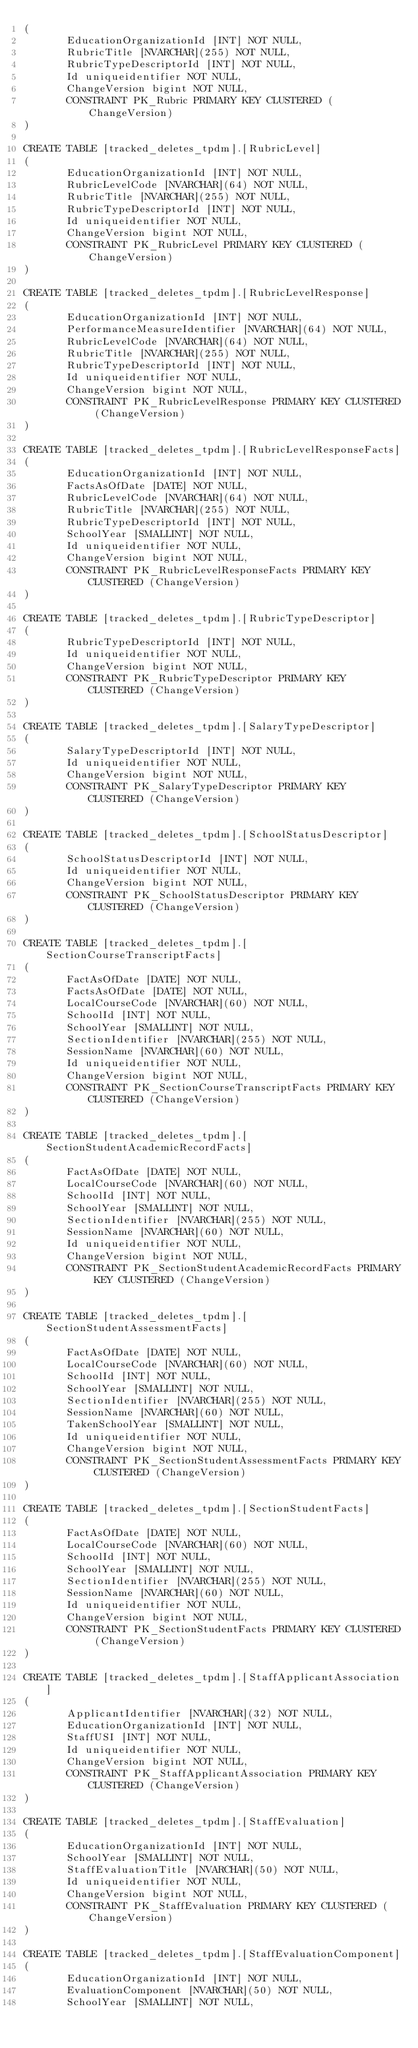<code> <loc_0><loc_0><loc_500><loc_500><_SQL_>(
       EducationOrganizationId [INT] NOT NULL,
       RubricTitle [NVARCHAR](255) NOT NULL,
       RubricTypeDescriptorId [INT] NOT NULL,
       Id uniqueidentifier NOT NULL,
       ChangeVersion bigint NOT NULL,
       CONSTRAINT PK_Rubric PRIMARY KEY CLUSTERED (ChangeVersion)
)

CREATE TABLE [tracked_deletes_tpdm].[RubricLevel]
(
       EducationOrganizationId [INT] NOT NULL,
       RubricLevelCode [NVARCHAR](64) NOT NULL,
       RubricTitle [NVARCHAR](255) NOT NULL,
       RubricTypeDescriptorId [INT] NOT NULL,
       Id uniqueidentifier NOT NULL,
       ChangeVersion bigint NOT NULL,
       CONSTRAINT PK_RubricLevel PRIMARY KEY CLUSTERED (ChangeVersion)
)

CREATE TABLE [tracked_deletes_tpdm].[RubricLevelResponse]
(
       EducationOrganizationId [INT] NOT NULL,
       PerformanceMeasureIdentifier [NVARCHAR](64) NOT NULL,
       RubricLevelCode [NVARCHAR](64) NOT NULL,
       RubricTitle [NVARCHAR](255) NOT NULL,
       RubricTypeDescriptorId [INT] NOT NULL,
       Id uniqueidentifier NOT NULL,
       ChangeVersion bigint NOT NULL,
       CONSTRAINT PK_RubricLevelResponse PRIMARY KEY CLUSTERED (ChangeVersion)
)

CREATE TABLE [tracked_deletes_tpdm].[RubricLevelResponseFacts]
(
       EducationOrganizationId [INT] NOT NULL,
       FactsAsOfDate [DATE] NOT NULL,
       RubricLevelCode [NVARCHAR](64) NOT NULL,
       RubricTitle [NVARCHAR](255) NOT NULL,
       RubricTypeDescriptorId [INT] NOT NULL,
       SchoolYear [SMALLINT] NOT NULL,
       Id uniqueidentifier NOT NULL,
       ChangeVersion bigint NOT NULL,
       CONSTRAINT PK_RubricLevelResponseFacts PRIMARY KEY CLUSTERED (ChangeVersion)
)

CREATE TABLE [tracked_deletes_tpdm].[RubricTypeDescriptor]
(
       RubricTypeDescriptorId [INT] NOT NULL,
       Id uniqueidentifier NOT NULL,
       ChangeVersion bigint NOT NULL,
       CONSTRAINT PK_RubricTypeDescriptor PRIMARY KEY CLUSTERED (ChangeVersion)
)

CREATE TABLE [tracked_deletes_tpdm].[SalaryTypeDescriptor]
(
       SalaryTypeDescriptorId [INT] NOT NULL,
       Id uniqueidentifier NOT NULL,
       ChangeVersion bigint NOT NULL,
       CONSTRAINT PK_SalaryTypeDescriptor PRIMARY KEY CLUSTERED (ChangeVersion)
)

CREATE TABLE [tracked_deletes_tpdm].[SchoolStatusDescriptor]
(
       SchoolStatusDescriptorId [INT] NOT NULL,
       Id uniqueidentifier NOT NULL,
       ChangeVersion bigint NOT NULL,
       CONSTRAINT PK_SchoolStatusDescriptor PRIMARY KEY CLUSTERED (ChangeVersion)
)

CREATE TABLE [tracked_deletes_tpdm].[SectionCourseTranscriptFacts]
(
       FactAsOfDate [DATE] NOT NULL,
       FactsAsOfDate [DATE] NOT NULL,
       LocalCourseCode [NVARCHAR](60) NOT NULL,
       SchoolId [INT] NOT NULL,
       SchoolYear [SMALLINT] NOT NULL,
       SectionIdentifier [NVARCHAR](255) NOT NULL,
       SessionName [NVARCHAR](60) NOT NULL,
       Id uniqueidentifier NOT NULL,
       ChangeVersion bigint NOT NULL,
       CONSTRAINT PK_SectionCourseTranscriptFacts PRIMARY KEY CLUSTERED (ChangeVersion)
)

CREATE TABLE [tracked_deletes_tpdm].[SectionStudentAcademicRecordFacts]
(
       FactAsOfDate [DATE] NOT NULL,
       LocalCourseCode [NVARCHAR](60) NOT NULL,
       SchoolId [INT] NOT NULL,
       SchoolYear [SMALLINT] NOT NULL,
       SectionIdentifier [NVARCHAR](255) NOT NULL,
       SessionName [NVARCHAR](60) NOT NULL,
       Id uniqueidentifier NOT NULL,
       ChangeVersion bigint NOT NULL,
       CONSTRAINT PK_SectionStudentAcademicRecordFacts PRIMARY KEY CLUSTERED (ChangeVersion)
)

CREATE TABLE [tracked_deletes_tpdm].[SectionStudentAssessmentFacts]
(
       FactAsOfDate [DATE] NOT NULL,
       LocalCourseCode [NVARCHAR](60) NOT NULL,
       SchoolId [INT] NOT NULL,
       SchoolYear [SMALLINT] NOT NULL,
       SectionIdentifier [NVARCHAR](255) NOT NULL,
       SessionName [NVARCHAR](60) NOT NULL,
       TakenSchoolYear [SMALLINT] NOT NULL,
       Id uniqueidentifier NOT NULL,
       ChangeVersion bigint NOT NULL,
       CONSTRAINT PK_SectionStudentAssessmentFacts PRIMARY KEY CLUSTERED (ChangeVersion)
)

CREATE TABLE [tracked_deletes_tpdm].[SectionStudentFacts]
(
       FactAsOfDate [DATE] NOT NULL,
       LocalCourseCode [NVARCHAR](60) NOT NULL,
       SchoolId [INT] NOT NULL,
       SchoolYear [SMALLINT] NOT NULL,
       SectionIdentifier [NVARCHAR](255) NOT NULL,
       SessionName [NVARCHAR](60) NOT NULL,
       Id uniqueidentifier NOT NULL,
       ChangeVersion bigint NOT NULL,
       CONSTRAINT PK_SectionStudentFacts PRIMARY KEY CLUSTERED (ChangeVersion)
)

CREATE TABLE [tracked_deletes_tpdm].[StaffApplicantAssociation]
(
       ApplicantIdentifier [NVARCHAR](32) NOT NULL,
       EducationOrganizationId [INT] NOT NULL,
       StaffUSI [INT] NOT NULL,
       Id uniqueidentifier NOT NULL,
       ChangeVersion bigint NOT NULL,
       CONSTRAINT PK_StaffApplicantAssociation PRIMARY KEY CLUSTERED (ChangeVersion)
)

CREATE TABLE [tracked_deletes_tpdm].[StaffEvaluation]
(
       EducationOrganizationId [INT] NOT NULL,
       SchoolYear [SMALLINT] NOT NULL,
       StaffEvaluationTitle [NVARCHAR](50) NOT NULL,
       Id uniqueidentifier NOT NULL,
       ChangeVersion bigint NOT NULL,
       CONSTRAINT PK_StaffEvaluation PRIMARY KEY CLUSTERED (ChangeVersion)
)

CREATE TABLE [tracked_deletes_tpdm].[StaffEvaluationComponent]
(
       EducationOrganizationId [INT] NOT NULL,
       EvaluationComponent [NVARCHAR](50) NOT NULL,
       SchoolYear [SMALLINT] NOT NULL,</code> 